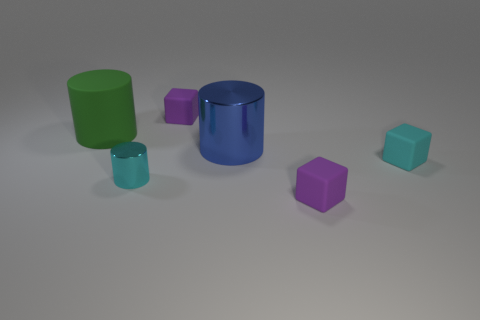Subtract all purple blocks. How many blocks are left? 1 Subtract all brown cylinders. How many purple blocks are left? 2 Subtract 1 cylinders. How many cylinders are left? 2 Add 3 green things. How many objects exist? 9 Subtract all blue cylinders. How many cylinders are left? 2 Subtract all yellow cylinders. Subtract all purple balls. How many cylinders are left? 3 Subtract 0 cyan spheres. How many objects are left? 6 Subtract all shiny cylinders. Subtract all small shiny objects. How many objects are left? 3 Add 3 big blue metal cylinders. How many big blue metal cylinders are left? 4 Add 2 green objects. How many green objects exist? 3 